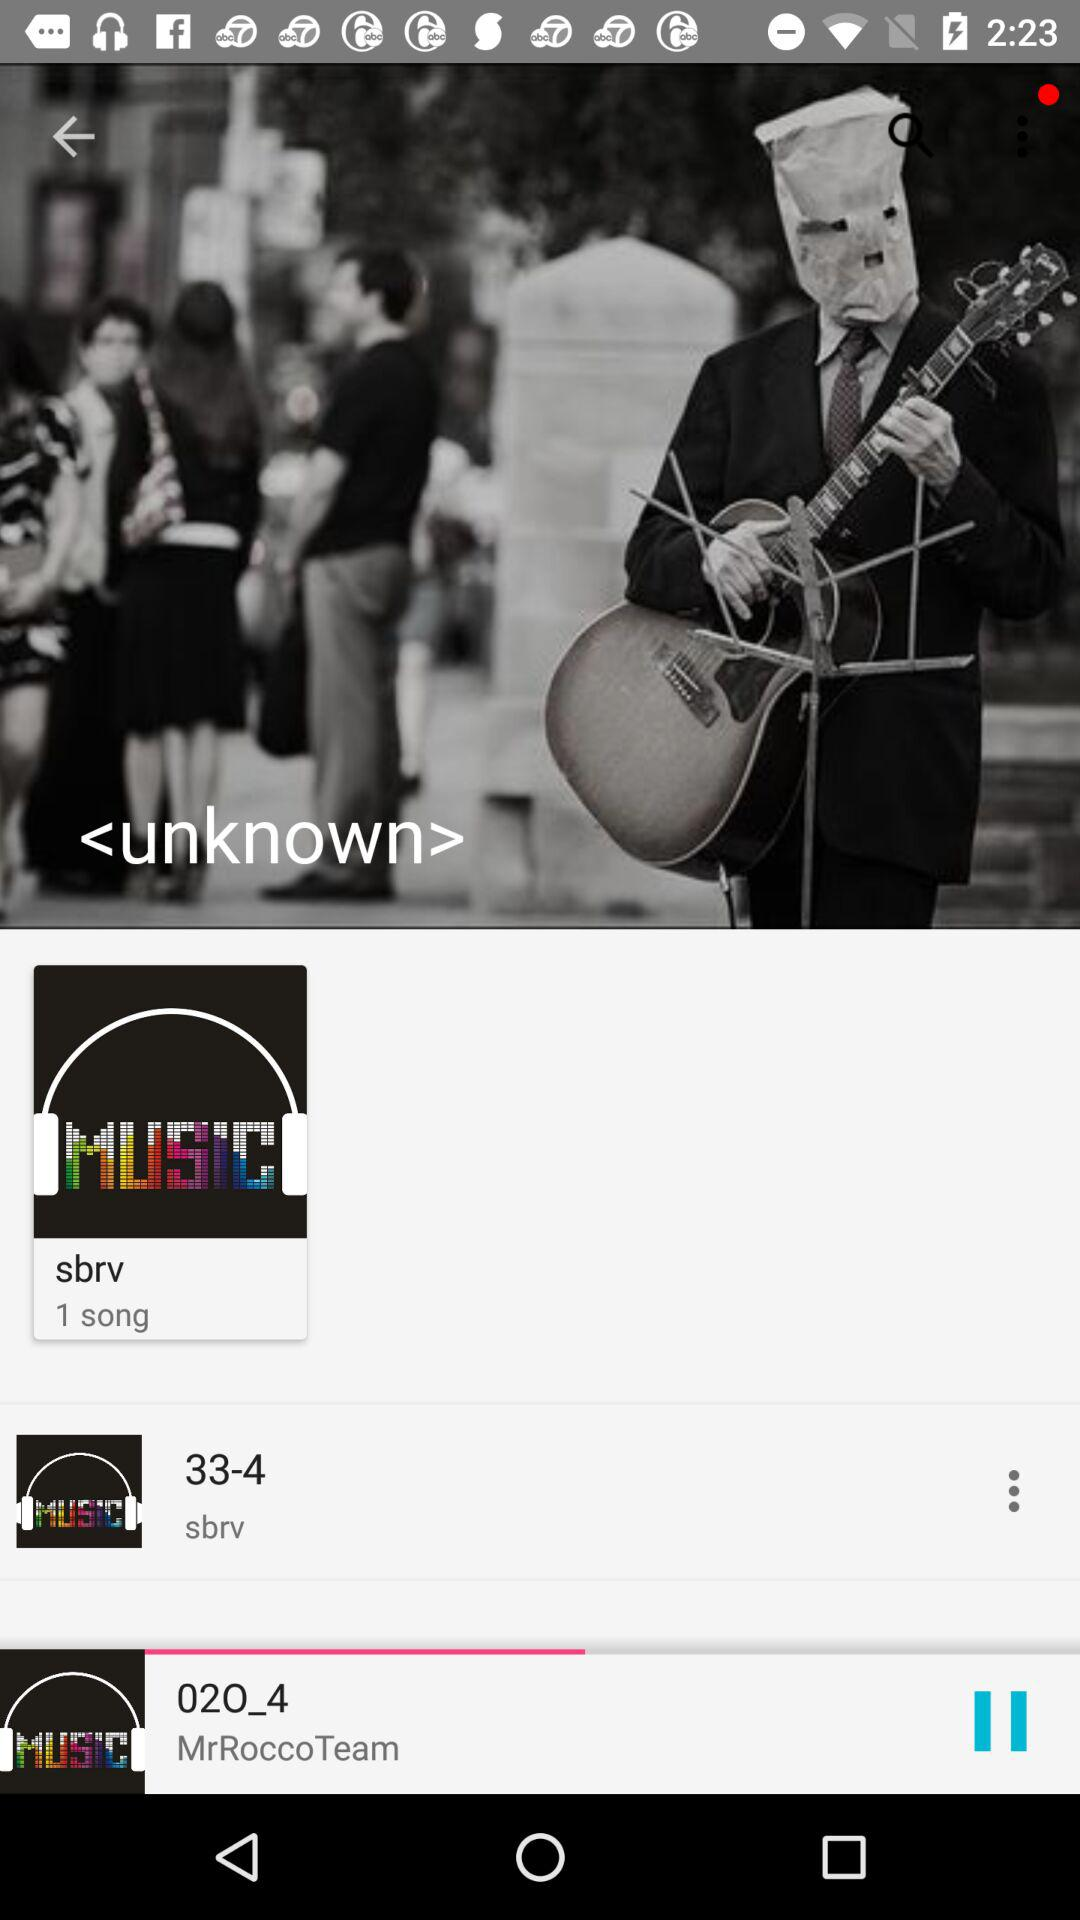How many total songs are there in sbrv? There is 1 song in sbrv. 